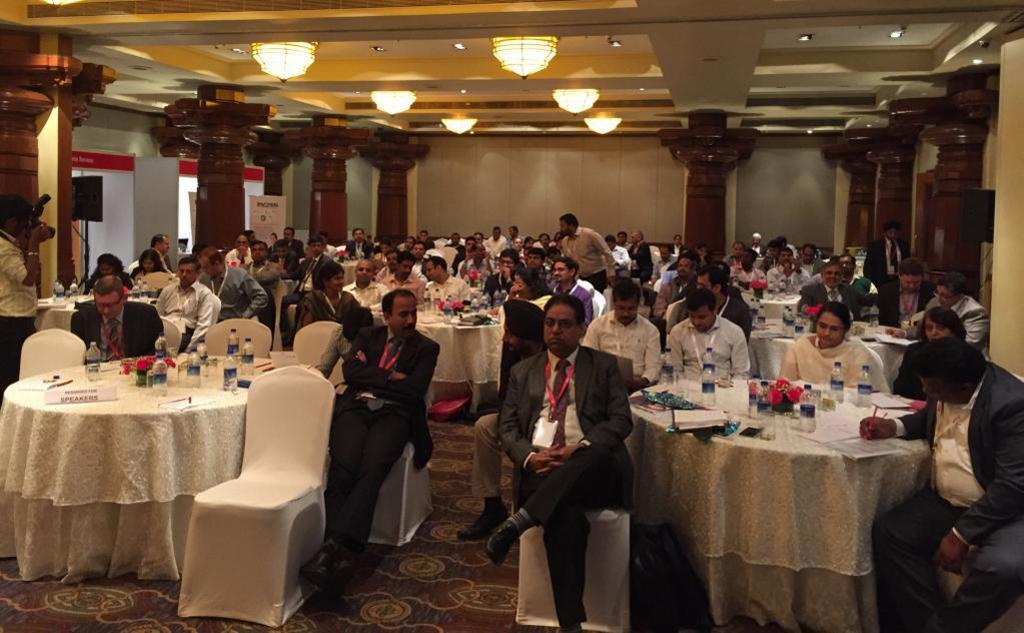How many people are in the image? There is a group of persons in the image. What are the persons in the image doing? The persons are sitting around a table. Where is the scene taking place? The setting is in a room. What type of punishment is being given to the person in the image? There is no indication of punishment in the image; the persons are simply sitting around a table. 